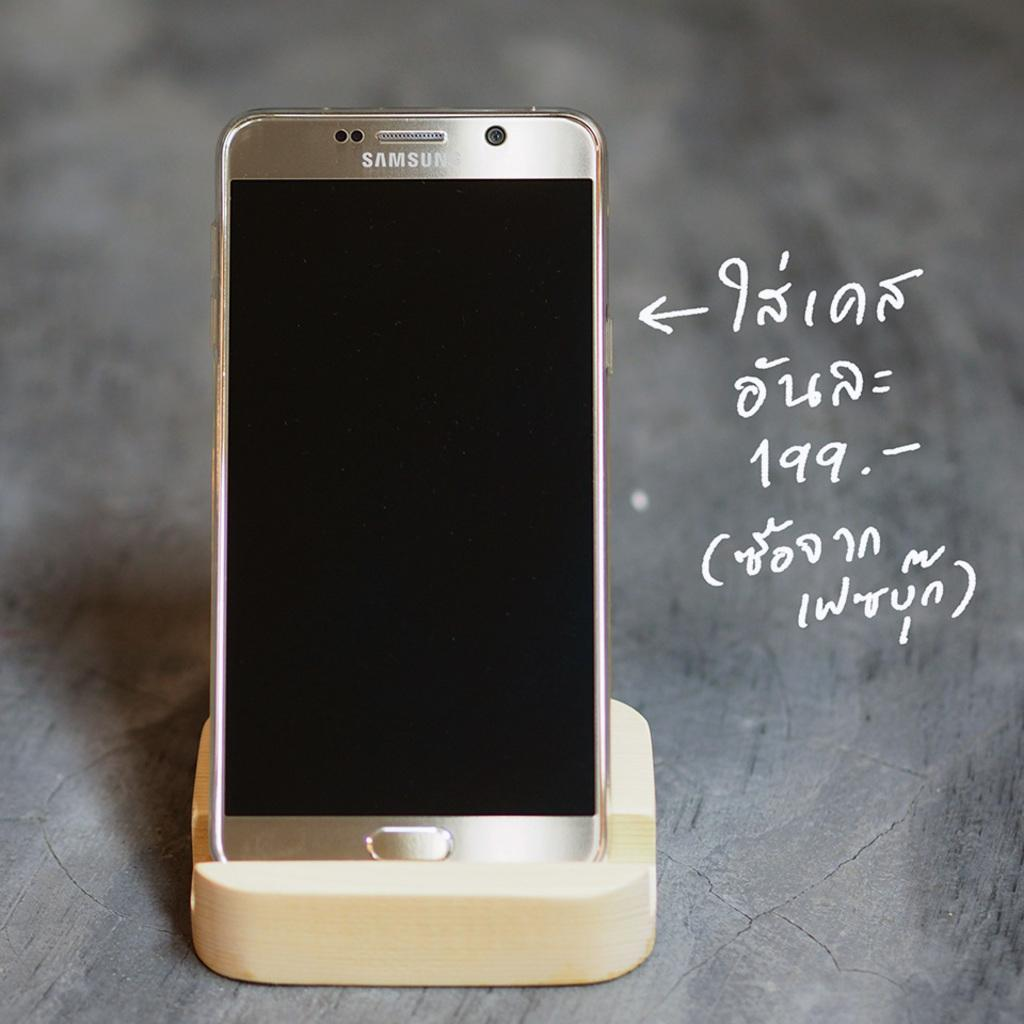<image>
Offer a succinct explanation of the picture presented. A Samsung phone sits on the charger with a formula written next to it. 